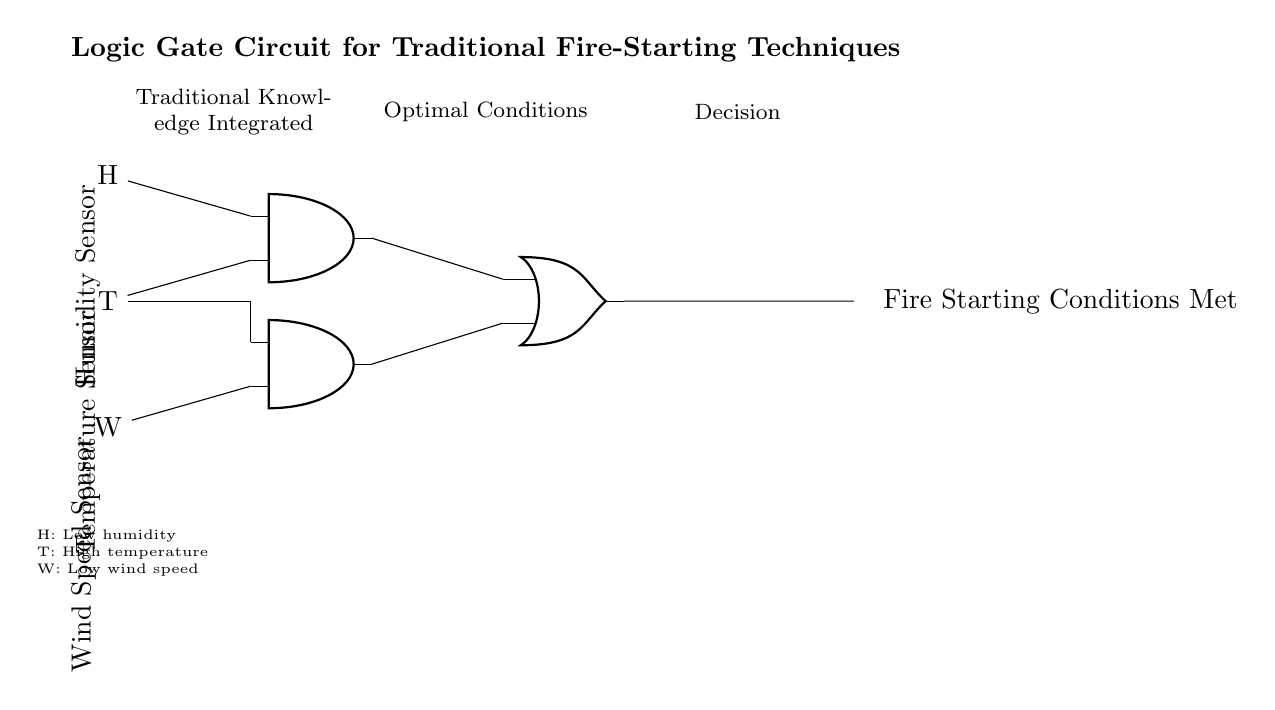What sensors are used in this circuit? The circuit uses three sensors: a humidity sensor, a temperature sensor, and a wind speed sensor. These are clearly labeled in the diagram as H, T, and W.
Answer: Humidity, Temperature, Wind Speed What does the output indicate? The output of the circuit is labeled as "Fire Starting Conditions Met," which indicates when the optimal conditions for starting a fire are achieved based on sensor inputs.
Answer: Fire Starting Conditions Met How many AND gates are in the circuit? There are two AND gates present in the circuit, as indicated by the two nodes labeled as AND ports.
Answer: 2 Which sensor contributes to both AND gates? The temperature sensor, labeled T in the diagram, connects to both AND gates, confirming its dual role in the logic of the circuit.
Answer: Temperature Sensor What condition is needed for AND gate one to output a signal? AND gate one requires a low humidity and high temperature for its output, meaning both conditions need to be met for it to send a signal to the OR gate.
Answer: Low humidity, High temperature What is the role of the OR gate in this circuit? The OR gate combines the outputs of the two AND gates and outputs a signal if either AND gate meets its conditions, thus determining whether fire starting conditions are met.
Answer: Combines outputs What are the defined conditions for optimal fire-starting in this circuit? The circuit defines optimal conditions as low humidity, high temperature, and low wind speed resulting in the fire starting conditions being met through the logic gates.
Answer: Low humidity, High temperature, Low wind speed 